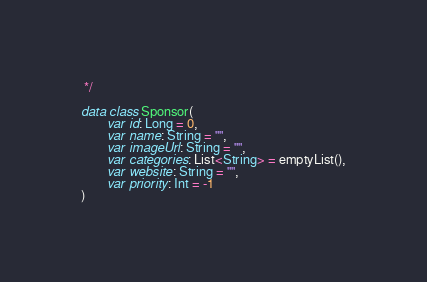Convert code to text. <code><loc_0><loc_0><loc_500><loc_500><_Kotlin_> */

data class Sponsor(
        var id: Long = 0,
        var name: String = "",
        var imageUrl: String = "",
        var categories: List<String> = emptyList(),
        var website: String = "",
        var priority: Int = -1
)</code> 